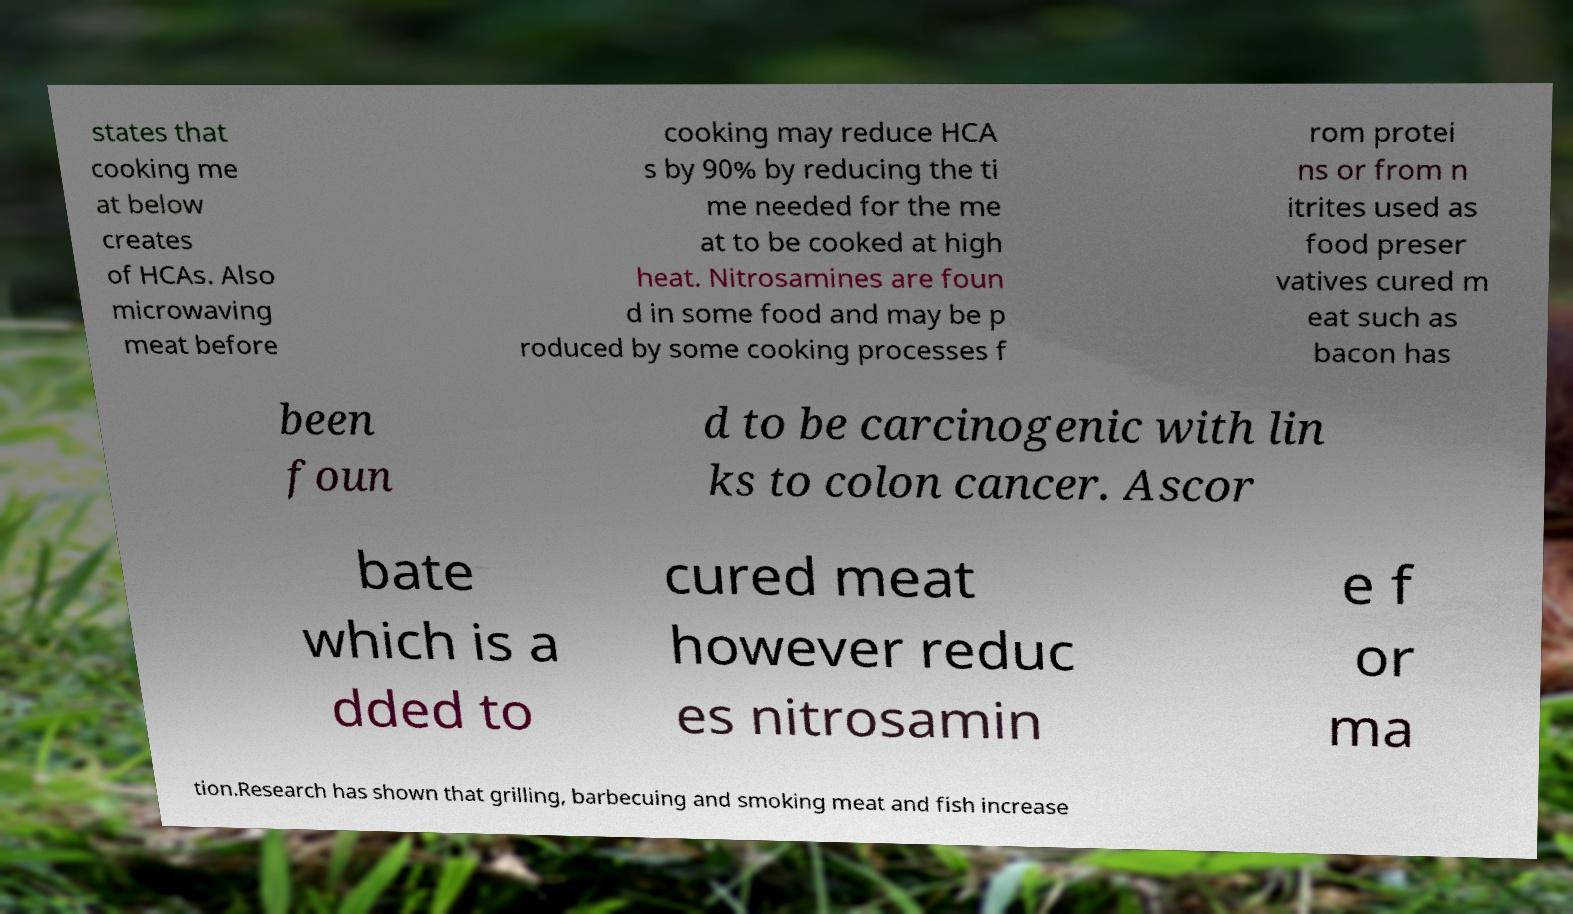Please read and relay the text visible in this image. What does it say? states that cooking me at below creates of HCAs. Also microwaving meat before cooking may reduce HCA s by 90% by reducing the ti me needed for the me at to be cooked at high heat. Nitrosamines are foun d in some food and may be p roduced by some cooking processes f rom protei ns or from n itrites used as food preser vatives cured m eat such as bacon has been foun d to be carcinogenic with lin ks to colon cancer. Ascor bate which is a dded to cured meat however reduc es nitrosamin e f or ma tion.Research has shown that grilling, barbecuing and smoking meat and fish increase 